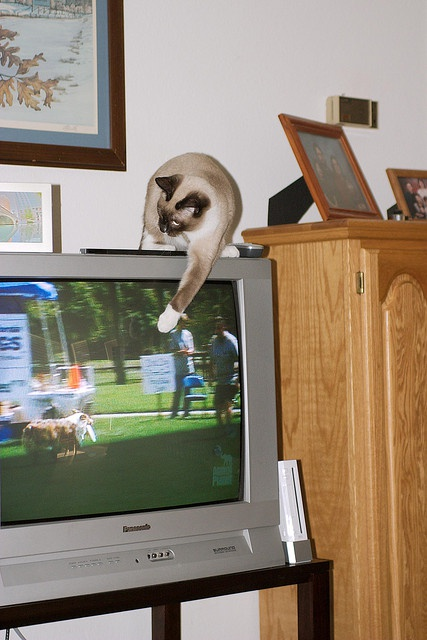Describe the objects in this image and their specific colors. I can see tv in gray, darkgray, and darkgreen tones, cat in gray, darkgray, and lightgray tones, and dog in gray, darkgreen, lightgray, and darkgray tones in this image. 